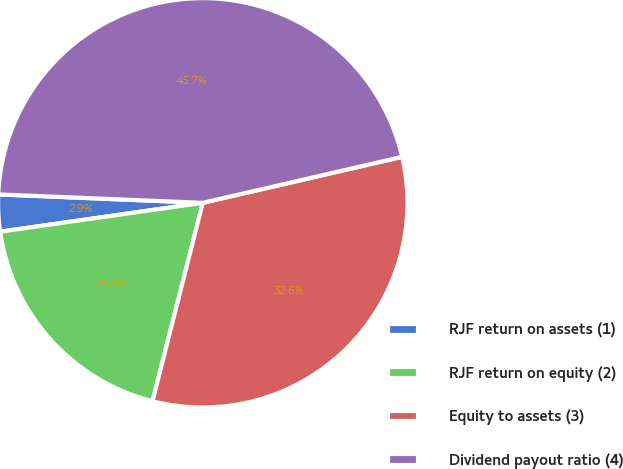Convert chart to OTSL. <chart><loc_0><loc_0><loc_500><loc_500><pie_chart><fcel>RJF return on assets (1)<fcel>RJF return on equity (2)<fcel>Equity to assets (3)<fcel>Dividend payout ratio (4)<nl><fcel>2.91%<fcel>18.8%<fcel>32.56%<fcel>45.74%<nl></chart> 